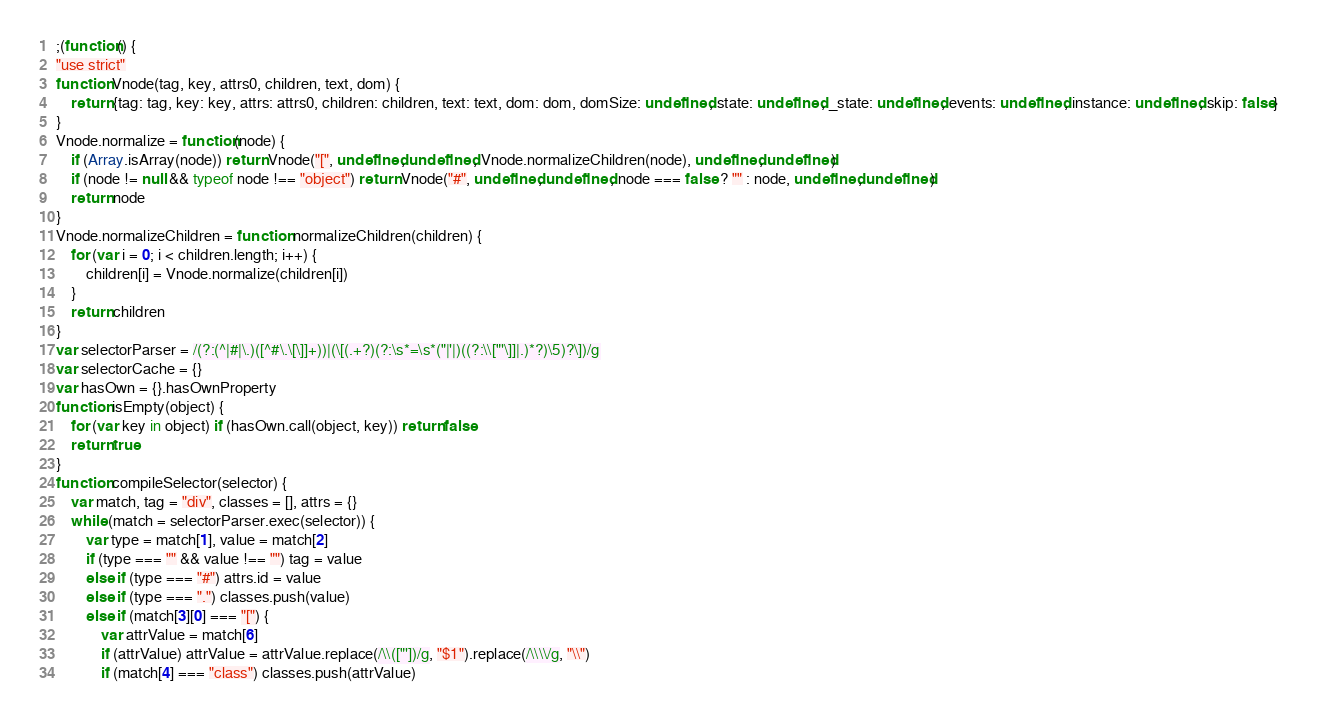Convert code to text. <code><loc_0><loc_0><loc_500><loc_500><_JavaScript_>;(function() {
"use strict"
function Vnode(tag, key, attrs0, children, text, dom) {
	return {tag: tag, key: key, attrs: attrs0, children: children, text: text, dom: dom, domSize: undefined, state: undefined, _state: undefined, events: undefined, instance: undefined, skip: false}
}
Vnode.normalize = function(node) {
	if (Array.isArray(node)) return Vnode("[", undefined, undefined, Vnode.normalizeChildren(node), undefined, undefined)
	if (node != null && typeof node !== "object") return Vnode("#", undefined, undefined, node === false ? "" : node, undefined, undefined)
	return node
}
Vnode.normalizeChildren = function normalizeChildren(children) {
	for (var i = 0; i < children.length; i++) {
		children[i] = Vnode.normalize(children[i])
	}
	return children
}
var selectorParser = /(?:(^|#|\.)([^#\.\[\]]+))|(\[(.+?)(?:\s*=\s*("|'|)((?:\\["'\]]|.)*?)\5)?\])/g
var selectorCache = {}
var hasOwn = {}.hasOwnProperty
function isEmpty(object) {
	for (var key in object) if (hasOwn.call(object, key)) return false
	return true
}
function compileSelector(selector) {
	var match, tag = "div", classes = [], attrs = {}
	while (match = selectorParser.exec(selector)) {
		var type = match[1], value = match[2]
		if (type === "" && value !== "") tag = value
		else if (type === "#") attrs.id = value
		else if (type === ".") classes.push(value)
		else if (match[3][0] === "[") {
			var attrValue = match[6]
			if (attrValue) attrValue = attrValue.replace(/\\(["'])/g, "$1").replace(/\\\\/g, "\\")
			if (match[4] === "class") classes.push(attrValue)</code> 